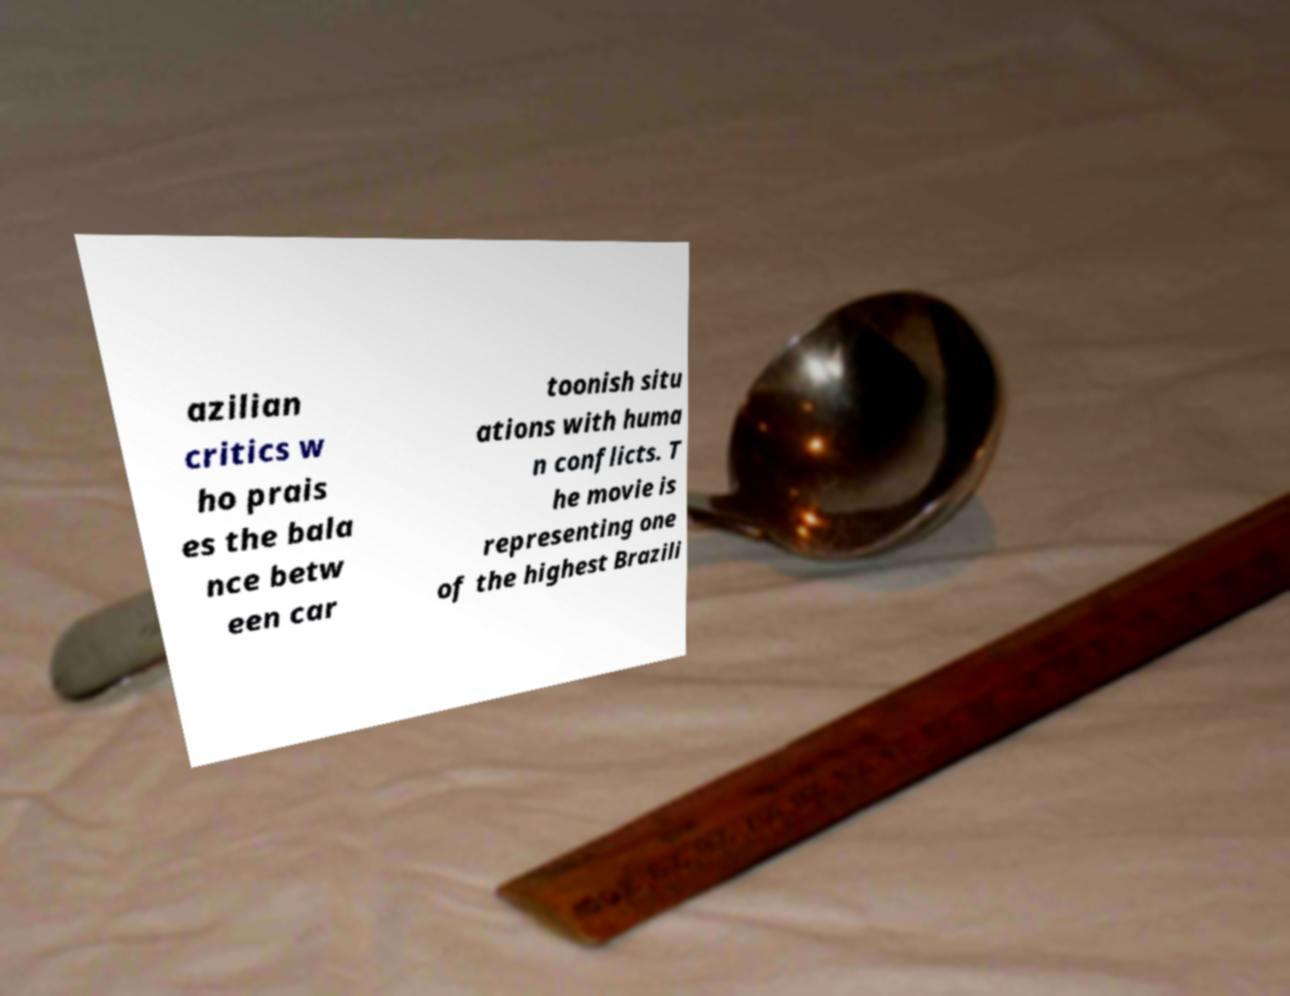Please identify and transcribe the text found in this image. azilian critics w ho prais es the bala nce betw een car toonish situ ations with huma n conflicts. T he movie is representing one of the highest Brazili 